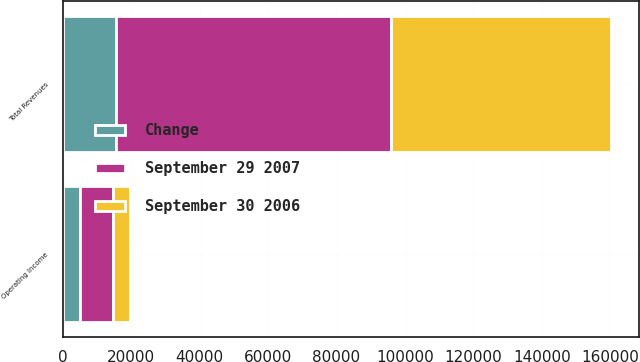<chart> <loc_0><loc_0><loc_500><loc_500><stacked_bar_chart><ecel><fcel>Total Revenues<fcel>Operating Income<nl><fcel>September 30 2006<fcel>64513<fcel>4817<nl><fcel>September 29 2007<fcel>80162<fcel>9760<nl><fcel>Change<fcel>15649<fcel>4943<nl></chart> 